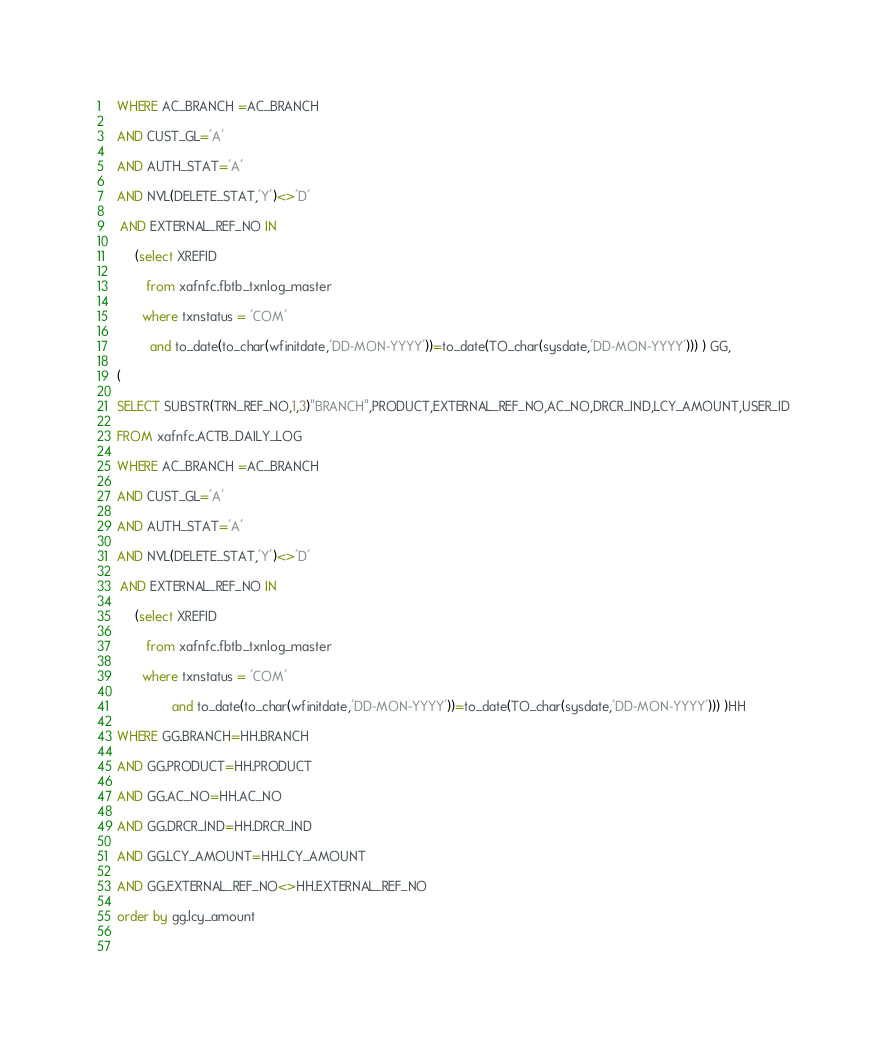Convert code to text. <code><loc_0><loc_0><loc_500><loc_500><_SQL_>
 WHERE AC_BRANCH =AC_BRANCH

 AND CUST_GL='A'

 AND AUTH_STAT='A'

 AND NVL(DELETE_STAT,'Y')<>'D'

  AND EXTERNAL_REF_NO IN

      (select XREFID

         from xafnfc.fbtb_txnlog_master

        where txnstatus = 'COM'

          and to_date(to_char(wfinitdate,'DD-MON-YYYY'))=to_date(TO_char(sysdate,'DD-MON-YYYY'))) ) GG,

 (

 SELECT SUBSTR(TRN_REF_NO,1,3)"BRANCH",PRODUCT,EXTERNAL_REF_NO,AC_NO,DRCR_IND,LCY_AMOUNT,USER_ID

 FROM xafnfc.ACTB_DAILY_LOG

 WHERE AC_BRANCH =AC_BRANCH

 AND CUST_GL='A'

 AND AUTH_STAT='A'

 AND NVL(DELETE_STAT,'Y')<>'D'

  AND EXTERNAL_REF_NO IN

      (select XREFID

         from xafnfc.fbtb_txnlog_master

        where txnstatus = 'COM'

                and to_date(to_char(wfinitdate,'DD-MON-YYYY'))=to_date(TO_char(sysdate,'DD-MON-YYYY'))) )HH

 WHERE GG.BRANCH=HH.BRANCH

 AND GG.PRODUCT=HH.PRODUCT

 AND GG.AC_NO=HH.AC_NO

 AND GG.DRCR_IND=HH.DRCR_IND

 AND GG.LCY_AMOUNT=HH.LCY_AMOUNT   

 AND GG.EXTERNAL_REF_NO<>HH.EXTERNAL_REF_NO  

 order by gg.lcy_amount  

 

</code> 